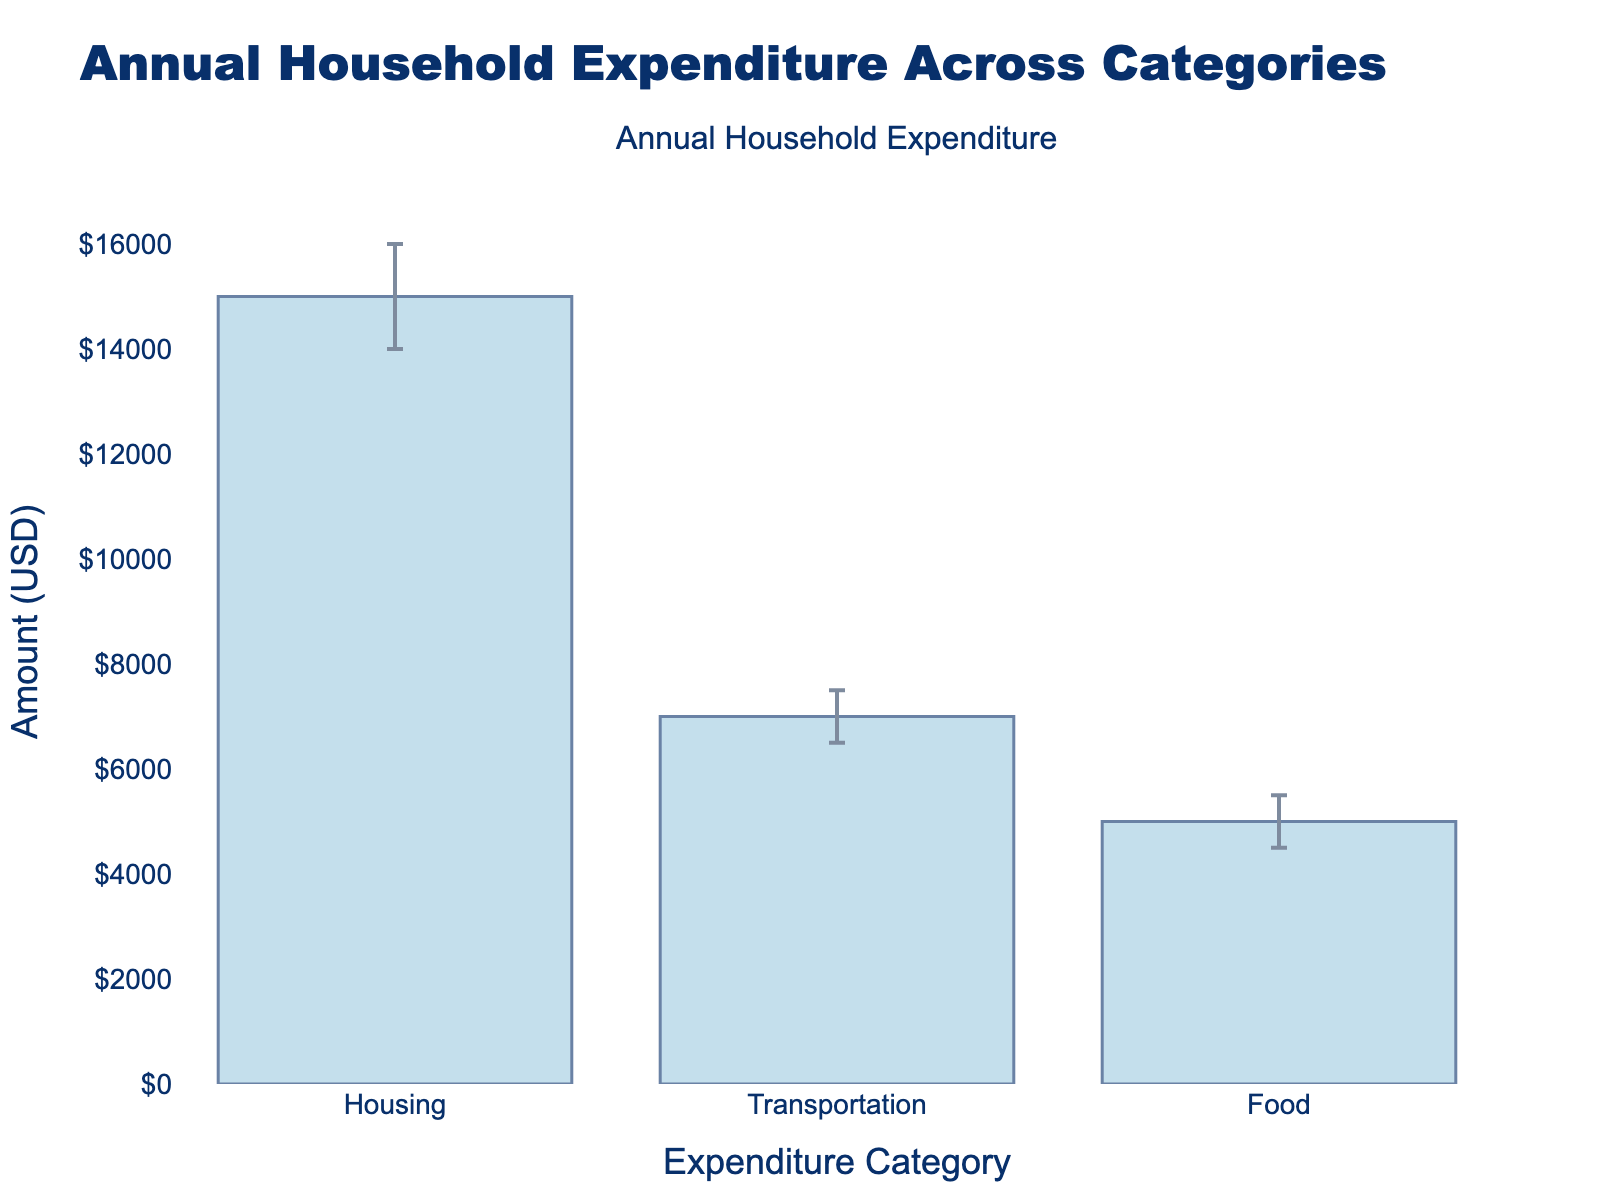what is the title of the figure? The title can be seen at the top of the figure. It reads "Annual Household Expenditure Across Categories".
Answer: Annual Household Expenditure Across Categories What is the highest mean expenditure category? The bar corresponding to "Housing" is the tallest, indicating the highest mean expenditure among the categories listed.
Answer: Housing What is the mean expenditure for Transportation? On the y-axis next to the bar labeled "Transportation", the mean expenditure value is given as $7000.
Answer: $7000 How does the mean expenditure for Food compare to Housing? The mean expenditure for Food is $5000, while for Housing it is $15000. Housing is $10000 more than Food.
Answer: Housing is $10000 more What range does the confidence interval for Transportation cover? The confidence interval for Transportation spans from the lower bound of $6500 to the upper bound of $7500.
Answer: $6500 to $7500 Which category has the smallest confidence interval range? The confidence interval range is smallest when the difference between the upper and lower bounds is minimal. For Food, the range is $1000 ($5500 - $4500).
Answer: Food What is the range of mean expenditure values shown in the figure? The lowest mean expenditure is $5000 for Food, and the highest is $15000 for Housing. So, the range is $5000 to $15000.
Answer: $5000 to $15000 What is the difference in the upper bound of the confidence interval between the highest and lowest expenditure categories? The upper bound for Housing is $16000, and for Food it is $5500. The difference is $16000 - $5500 = $10500.
Answer: $10500 What is the color of the bars representing mean expenditures in the chart? The bars are colored in a light blue shade.
Answer: light blue Which category has the widest confidence interval in terms of actual expenditure amount? The confidence interval for Housing spans from $14000 to $16000, with a range of $2000. This is wider than the intervals for Transportation ($1000) and Food ($1000).
Answer: Housing 